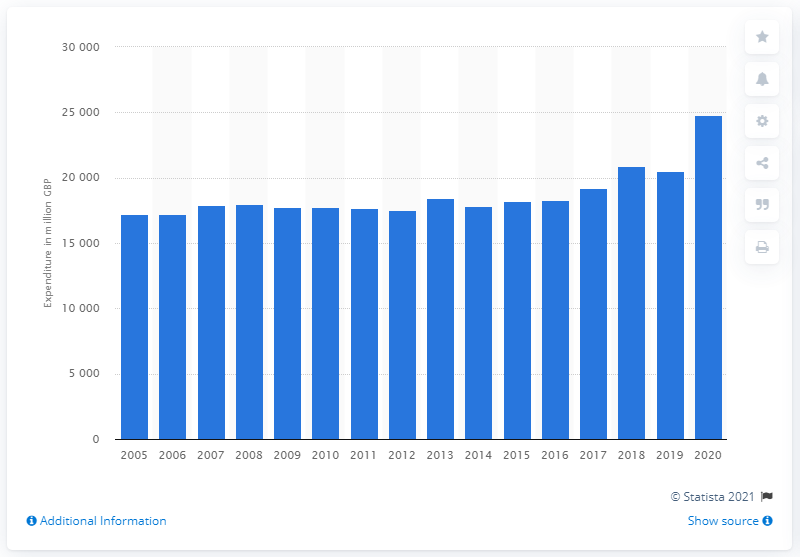Specify some key components in this picture. The purchases of alcoholic beverages increased between 2019 and 2020. 